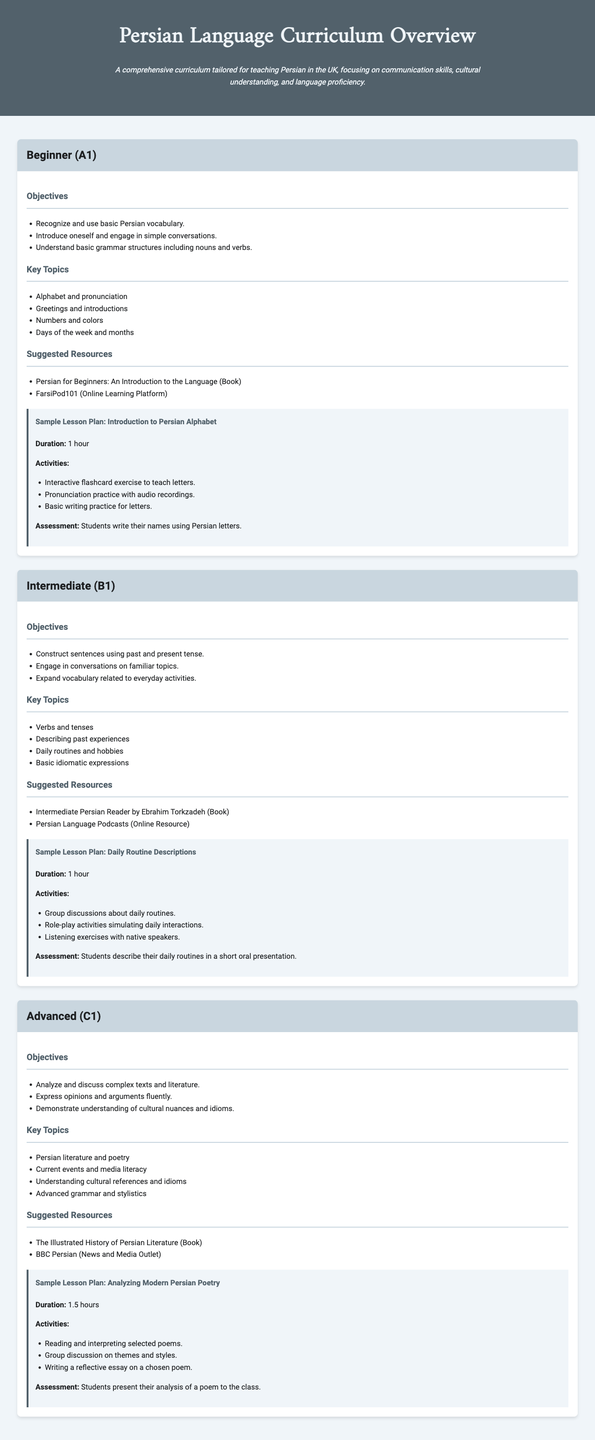What is the title of the document? The title of the document is found in the head section and represents the content, which is "Persian Language Curriculum Overview."
Answer: Persian Language Curriculum Overview What is the duration of the sample lesson plan for the Beginner level? The duration is specified within the lesson plan section for the Beginner level, which states "1 hour."
Answer: 1 hour What level of the curriculum is focused on discussing complex texts and literature? The level that discusses complex texts and literature is detailed in the Advanced section, which is labeled C1.
Answer: C1 Which online resource is suggested for beginner learners? The suggested resource for beginners is stated clearly within the relevant section, which is "FarsiPod101."
Answer: FarsiPod101 How many key topics are listed for the Intermediate level? The number of key topics can be determined by counting the items listed under the Intermediate (B1) section, which includes four topics.
Answer: 4 What is the primary objective for Beginners in this curriculum? The first objective mentioned under the Beginner level specifies basic vocabulary recognition and usage.
Answer: Recognize and use basic Persian vocabulary How long is the sample lesson plan for analyzing modern Persian poetry? The duration for this lesson plan is noted in the lesson plan section for the Advanced level, stating "1.5 hours."
Answer: 1.5 hours What type of expressions are covered in the Intermediate level? The Intermediate level covers basic idiomatic expressions as indicated in the key topics list.
Answer: Basic idiomatic expressions Which book is recommended for the Advanced level? The recommended book for advanced learners is clearly mentioned, which is "The Illustrated History of Persian Literature."
Answer: The Illustrated History of Persian Literature 